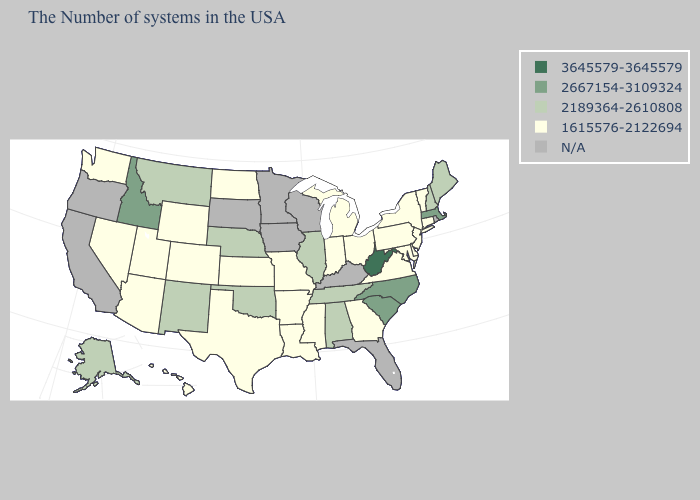What is the value of Illinois?
Be succinct. 2189364-2610808. Name the states that have a value in the range 2189364-2610808?
Write a very short answer. Maine, New Hampshire, Alabama, Tennessee, Illinois, Nebraska, Oklahoma, New Mexico, Montana, Alaska. What is the value of Minnesota?
Write a very short answer. N/A. What is the value of Arizona?
Short answer required. 1615576-2122694. Does Maine have the lowest value in the Northeast?
Keep it brief. No. Does the first symbol in the legend represent the smallest category?
Be succinct. No. Does the map have missing data?
Give a very brief answer. Yes. Does Maine have the lowest value in the USA?
Keep it brief. No. What is the highest value in the Northeast ?
Be succinct. 2667154-3109324. What is the value of Illinois?
Short answer required. 2189364-2610808. Is the legend a continuous bar?
Write a very short answer. No. Does Pennsylvania have the lowest value in the USA?
Give a very brief answer. Yes. Which states have the highest value in the USA?
Answer briefly. West Virginia. 